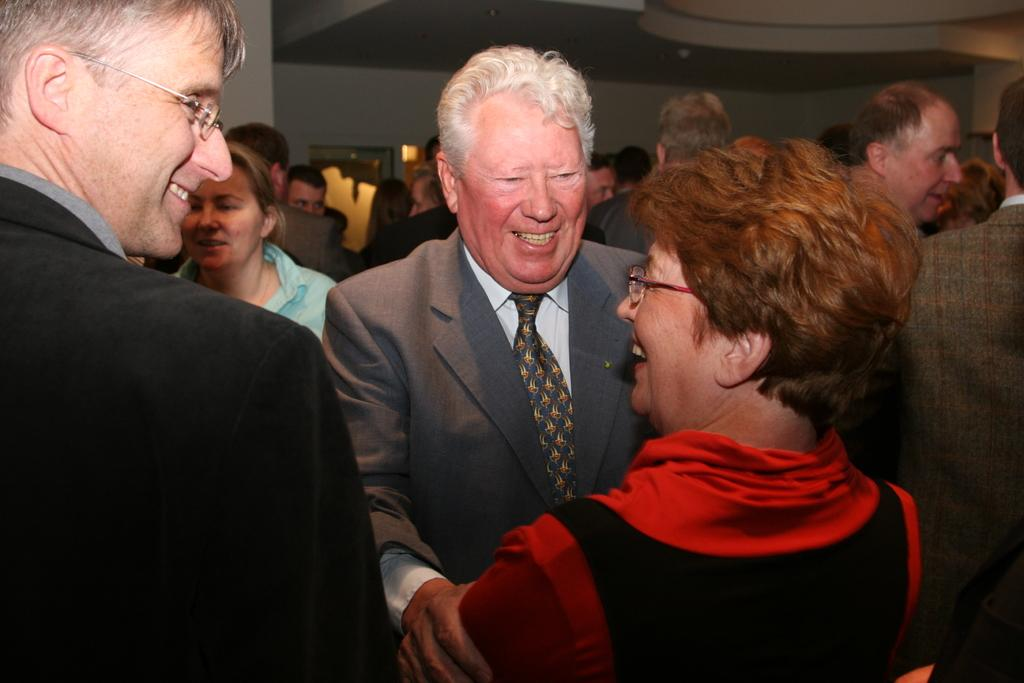What is the main subject in the foreground of the picture? There is a woman and two men in the foreground of the picture. What are the men doing in the foreground of the picture? The men are standing and smiling in the foreground of the picture. What can be seen in the background of the picture? There is a crowd, a wall, lights, and the ceiling visible in the background of the picture. How many rabbits can be seen holding a string in the image? There are no rabbits or strings present in the image. What type of quill is being used by the woman in the image? There is no quill visible in the image; the woman is not holding or using any writing instrument. 